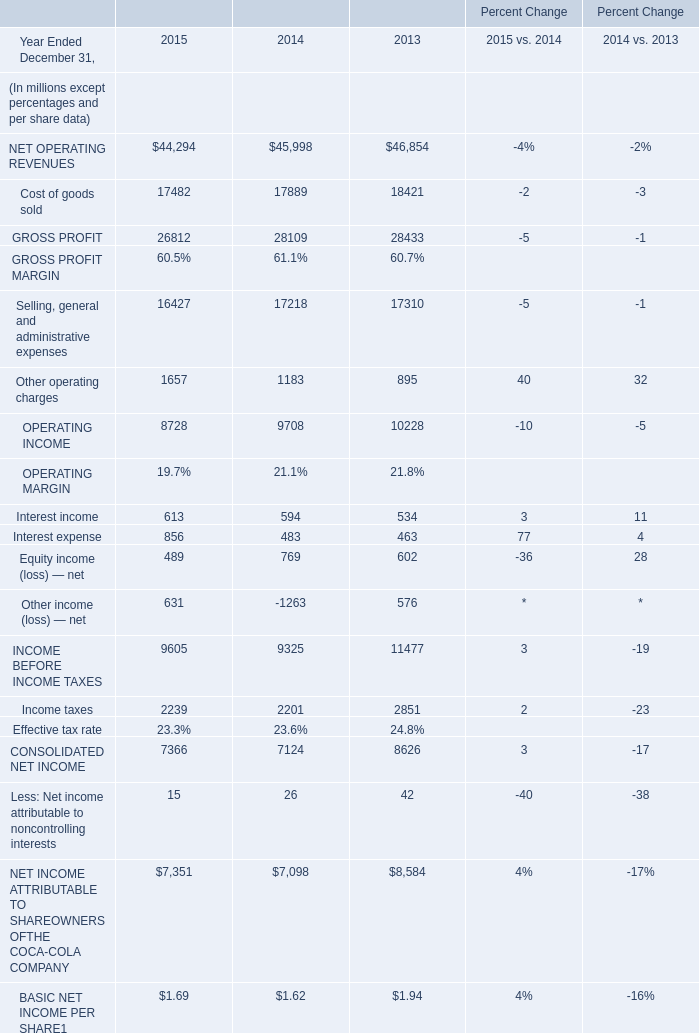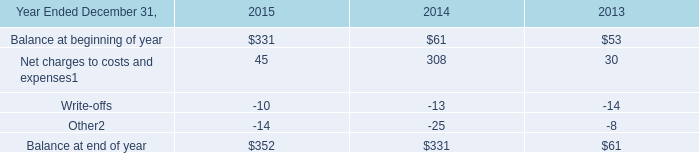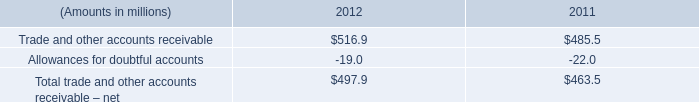What's the total amount of the Other operating charges in the years where Net charges to costs and expenses1 is greater than 0? (in million) 
Computations: ((1657 + 1183) + 895)
Answer: 3735.0. 